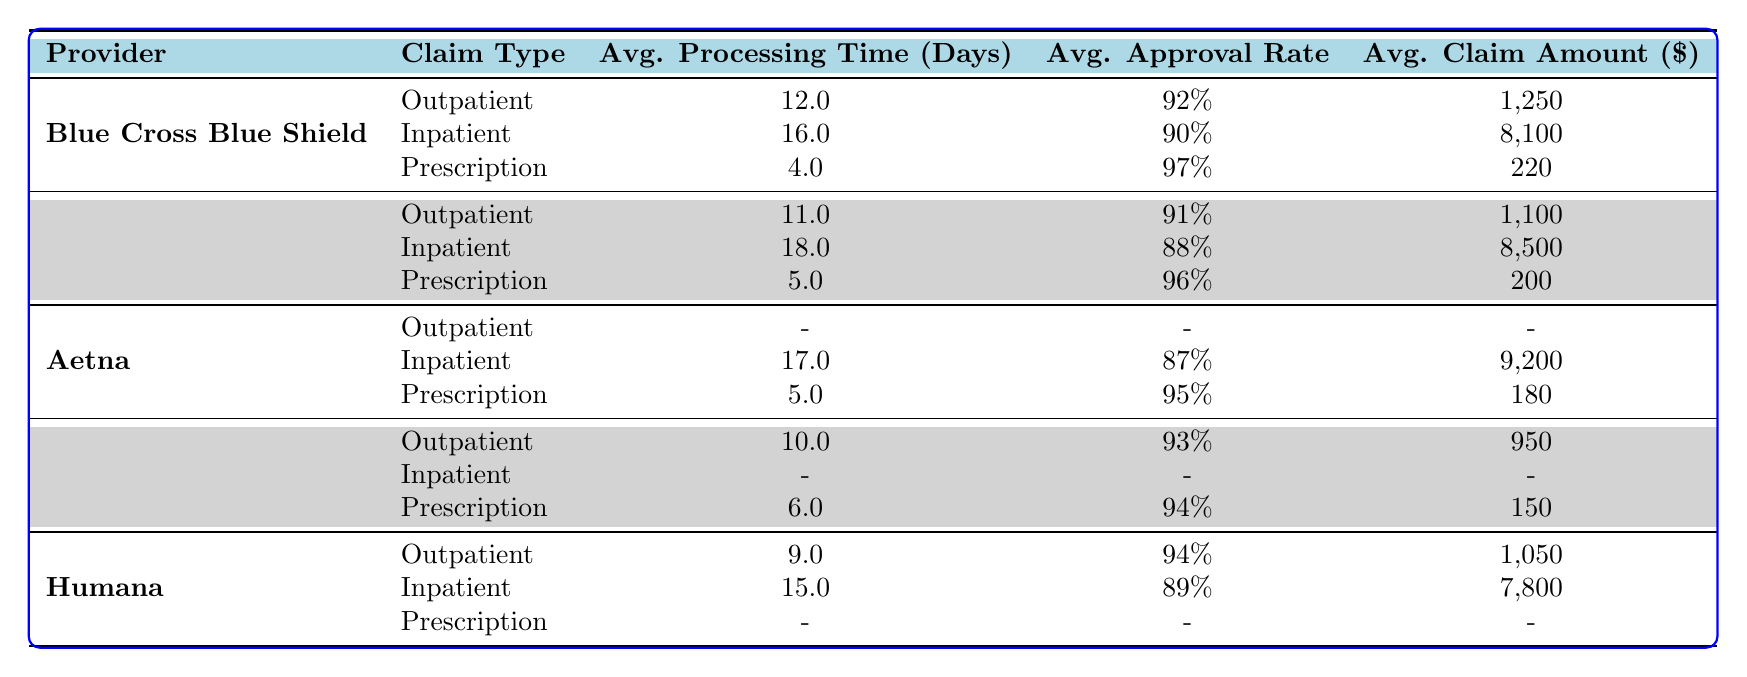What is the average processing time for claims submitted to Aetna? Aetna has submitted two claims with processing times: 17 days for inpatient and 5 days for prescription. To find the average, we add these two numbers (17 + 5 = 22) and divide by 2, giving us an average processing time of 22/2 = 11 days.
Answer: 11 days Which provider has the highest approval rate for outpatient claims? Blue Cross Blue Shield has the highest approval rate for outpatient claims at 92%. Cigna follows with 93%, and UnitedHealthcare is at 91%. Comparing these values shows that Cigna, with an approval rate of 93%, is the highest.
Answer: Cigna Is the average claim amount for Humana's inpatient claims greater than 7800? Humana's only inpatient claim amount is 7800. Therefore, the average claim amount for Humana's inpatient claims is equal to 7800, not greater than it.
Answer: No What is the total average processing time for inpatient claims across all providers? To find the total average processing time for inpatient claims, we need the processing times from each provider: Blue Cross Blue Shield (16), UnitedHealthcare (18), Aetna (17), and Humana (15). Adding these gives: 16 + 18 + 17 + 15 = 66. There are 4 data points, so the total average is 66/4 = 16.5 days.
Answer: 16.5 days What is the approval rate for UnitedHealthcare's outpatient claims? According to the table, UnitedHealthcare's outpatient claim has an approval rate of 91%.
Answer: 91% What is the claim amount for the Prescription claims processed by Cigna? The table shows that for Cigna, the claim amount for the Prescription claim is 150.
Answer: 150 